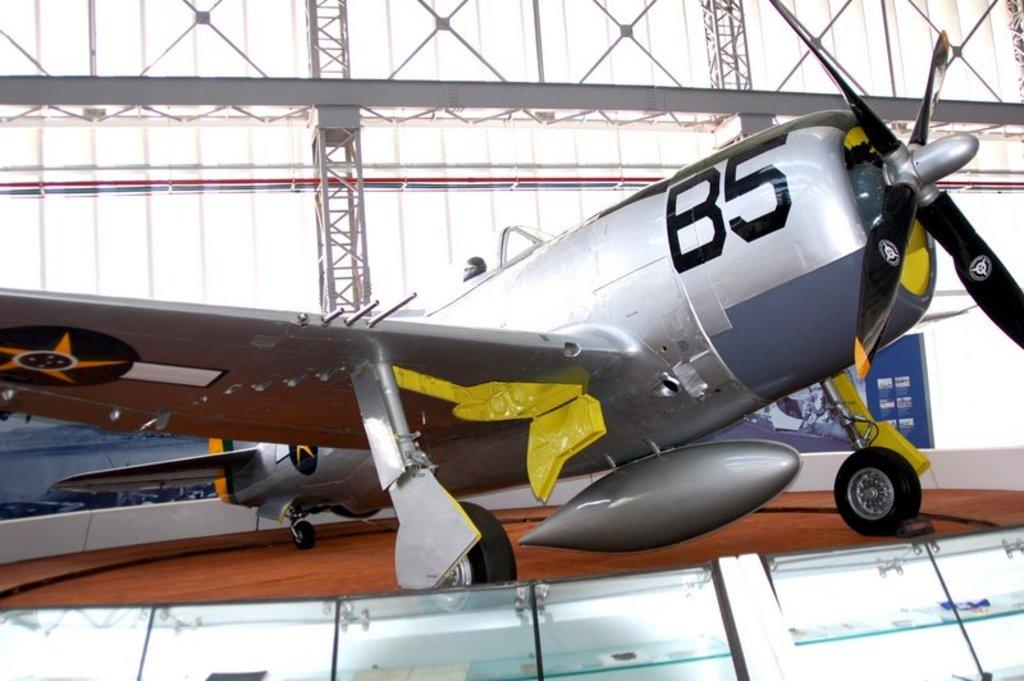What is the main subject in the center of the image? There is a glider in the center of the image. What can be seen in the background of the image? There are rods in the background of the image. What type of worm can be seen crawling on the glider in the image? There is no worm present in the image; it only features a glider and rods in the background. 